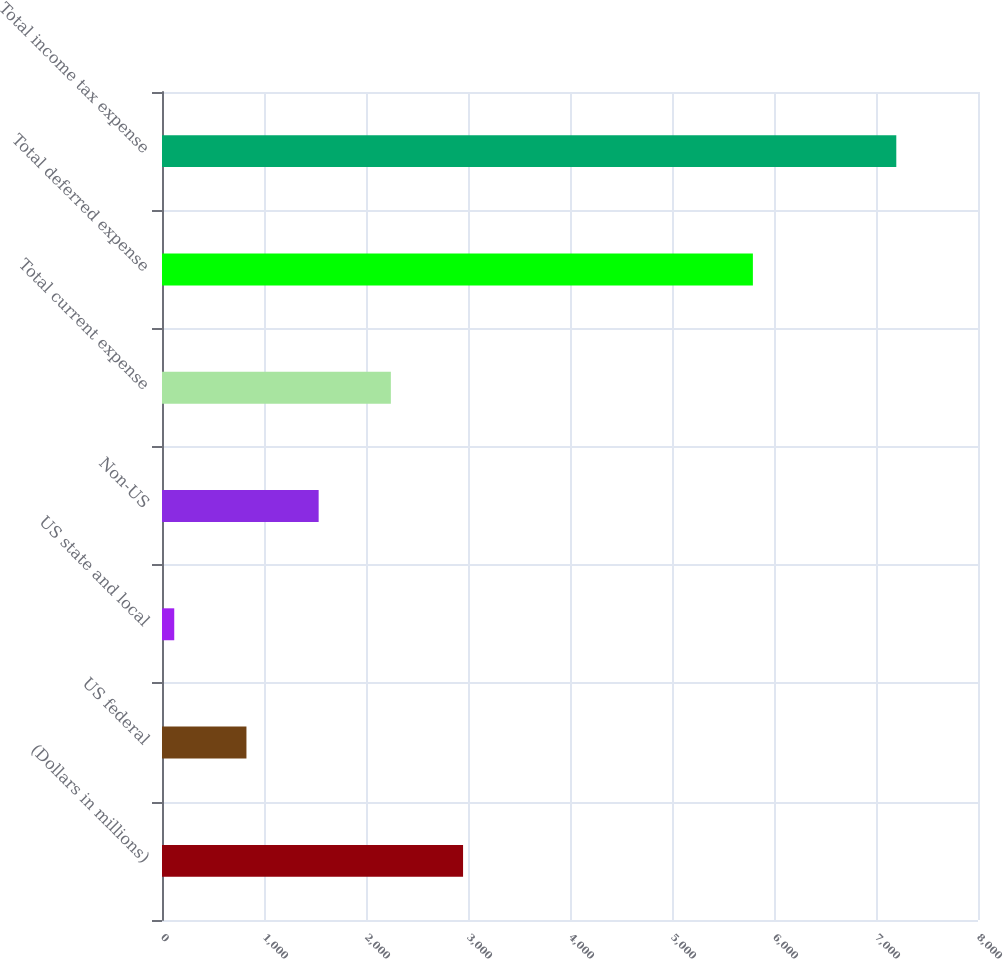Convert chart to OTSL. <chart><loc_0><loc_0><loc_500><loc_500><bar_chart><fcel>(Dollars in millions)<fcel>US federal<fcel>US state and local<fcel>Non-US<fcel>Total current expense<fcel>Total deferred expense<fcel>Total income tax expense<nl><fcel>2951.6<fcel>827.9<fcel>120<fcel>1535.8<fcel>2243.7<fcel>5793<fcel>7199<nl></chart> 